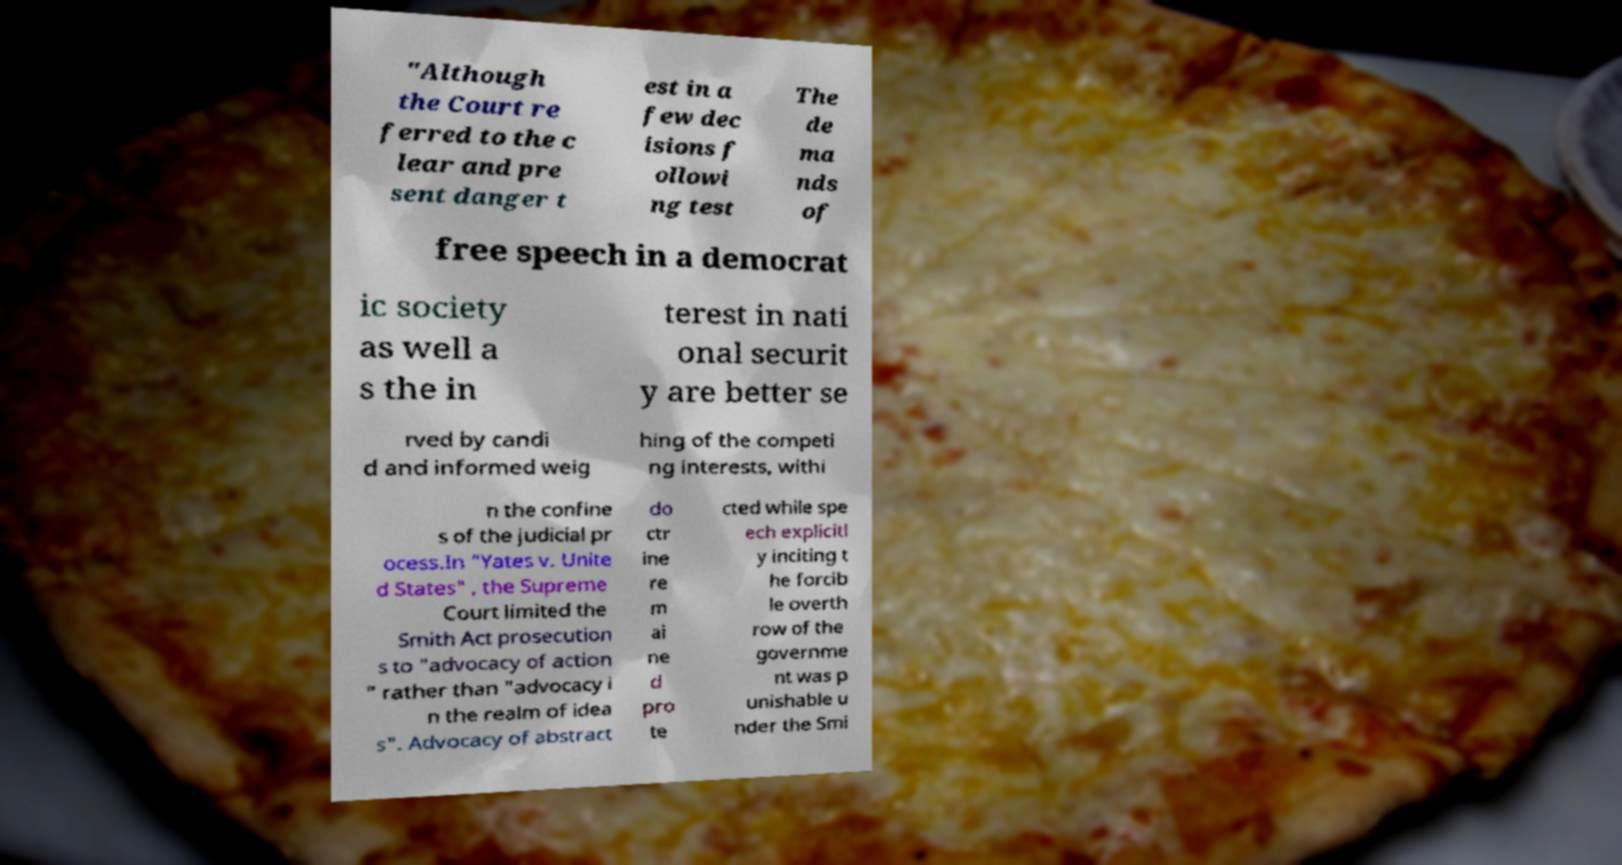Can you accurately transcribe the text from the provided image for me? "Although the Court re ferred to the c lear and pre sent danger t est in a few dec isions f ollowi ng test The de ma nds of free speech in a democrat ic society as well a s the in terest in nati onal securit y are better se rved by candi d and informed weig hing of the competi ng interests, withi n the confine s of the judicial pr ocess.In "Yates v. Unite d States" , the Supreme Court limited the Smith Act prosecution s to "advocacy of action " rather than "advocacy i n the realm of idea s". Advocacy of abstract do ctr ine re m ai ne d pro te cted while spe ech explicitl y inciting t he forcib le overth row of the governme nt was p unishable u nder the Smi 